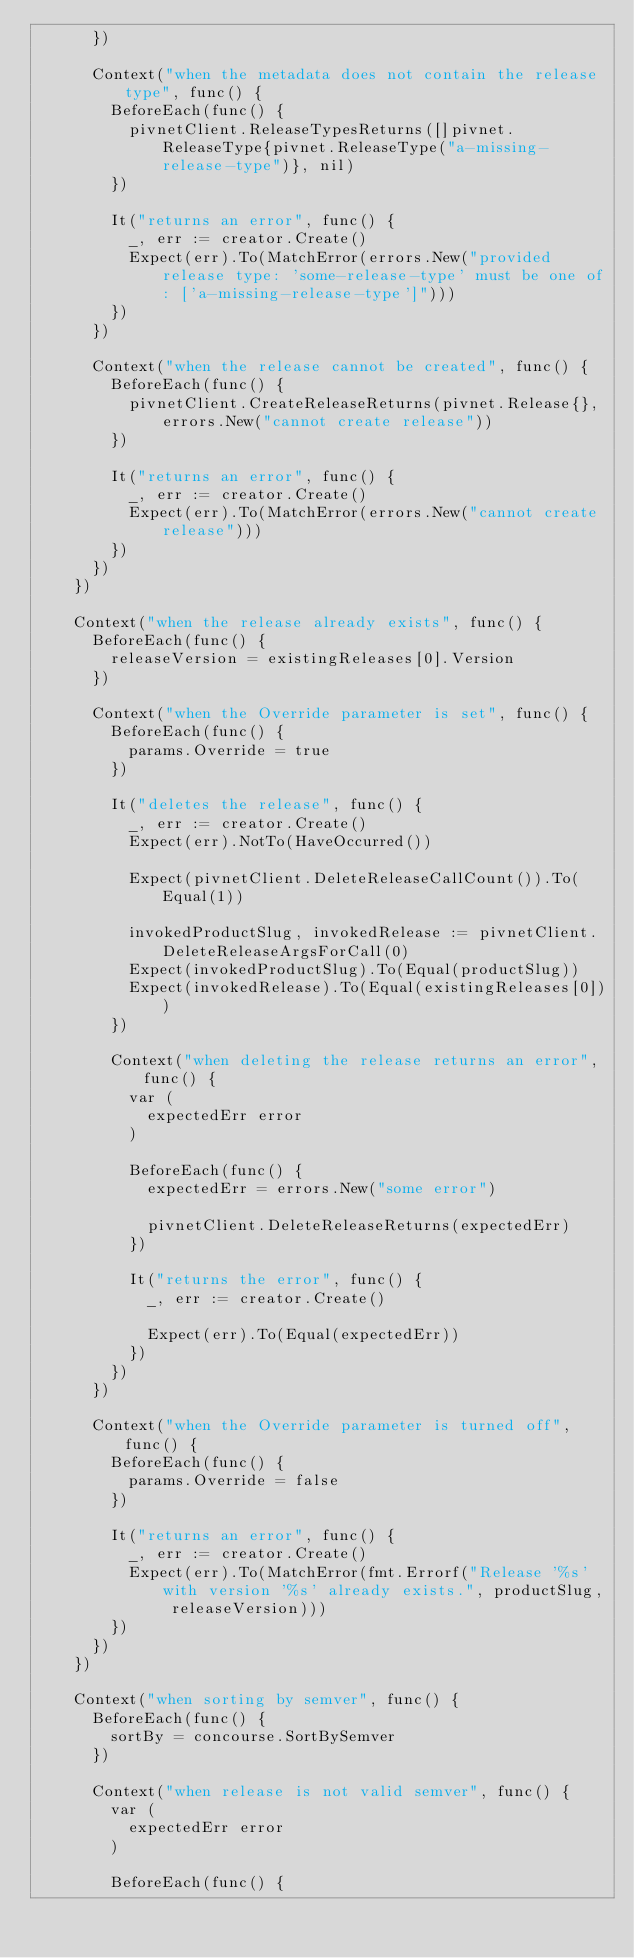<code> <loc_0><loc_0><loc_500><loc_500><_Go_>			})

			Context("when the metadata does not contain the release type", func() {
				BeforeEach(func() {
					pivnetClient.ReleaseTypesReturns([]pivnet.ReleaseType{pivnet.ReleaseType("a-missing-release-type")}, nil)
				})

				It("returns an error", func() {
					_, err := creator.Create()
					Expect(err).To(MatchError(errors.New("provided release type: 'some-release-type' must be one of: ['a-missing-release-type']")))
				})
			})

			Context("when the release cannot be created", func() {
				BeforeEach(func() {
					pivnetClient.CreateReleaseReturns(pivnet.Release{}, errors.New("cannot create release"))
				})

				It("returns an error", func() {
					_, err := creator.Create()
					Expect(err).To(MatchError(errors.New("cannot create release")))
				})
			})
		})

		Context("when the release already exists", func() {
			BeforeEach(func() {
				releaseVersion = existingReleases[0].Version
			})

			Context("when the Override parameter is set", func() {
				BeforeEach(func() {
					params.Override = true
				})

				It("deletes the release", func() {
					_, err := creator.Create()
					Expect(err).NotTo(HaveOccurred())

					Expect(pivnetClient.DeleteReleaseCallCount()).To(Equal(1))

					invokedProductSlug, invokedRelease := pivnetClient.DeleteReleaseArgsForCall(0)
					Expect(invokedProductSlug).To(Equal(productSlug))
					Expect(invokedRelease).To(Equal(existingReleases[0]))
				})

				Context("when deleting the release returns an error", func() {
					var (
						expectedErr error
					)

					BeforeEach(func() {
						expectedErr = errors.New("some error")

						pivnetClient.DeleteReleaseReturns(expectedErr)
					})

					It("returns the error", func() {
						_, err := creator.Create()

						Expect(err).To(Equal(expectedErr))
					})
				})
			})

			Context("when the Override parameter is turned off", func() {
				BeforeEach(func() {
					params.Override = false
				})

				It("returns an error", func() {
					_, err := creator.Create()
					Expect(err).To(MatchError(fmt.Errorf("Release '%s' with version '%s' already exists.", productSlug, releaseVersion)))
				})
			})
		})

		Context("when sorting by semver", func() {
			BeforeEach(func() {
				sortBy = concourse.SortBySemver
			})

			Context("when release is not valid semver", func() {
				var (
					expectedErr error
				)

				BeforeEach(func() {</code> 